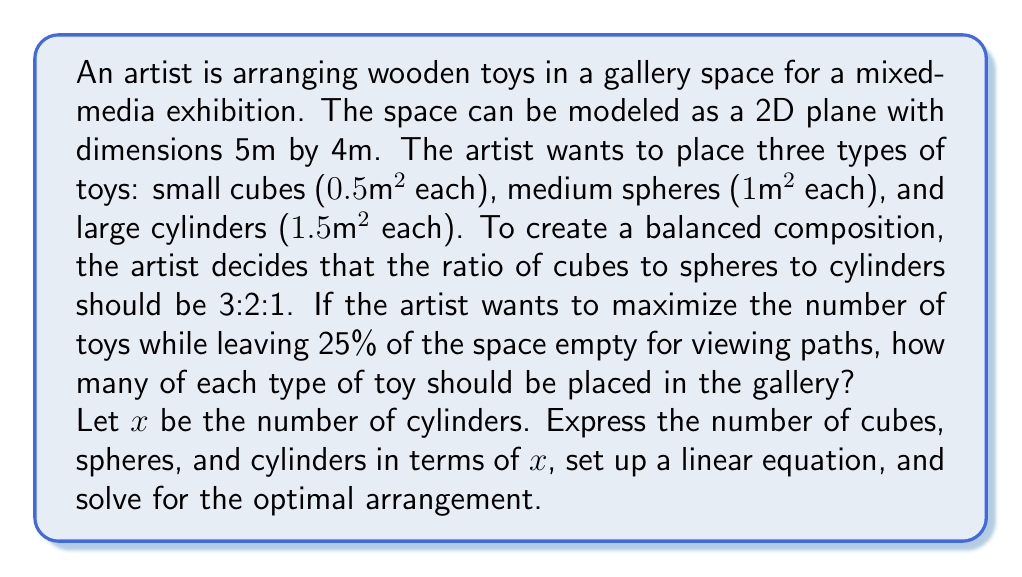Solve this math problem. Let's approach this problem step-by-step:

1) First, let's define our variables:
   $x$ = number of cylinders
   $3x$ = number of cubes (3 times the cylinders)
   $2x$ = number of spheres (2 times the cylinders)

2) Calculate the total area of the gallery:
   $$\text{Total Area} = 5m \times 4m = 20m^2$$

3) Calculate the available area for toys (75% of total):
   $$\text{Available Area} = 0.75 \times 20m^2 = 15m^2$$

4) Set up the equation based on the area occupied by toys:
   $$0.5m^2(3x) + 1m^2(2x) + 1.5m^2(x) = 15m^2$$

5) Simplify the equation:
   $$1.5x + 2x + 1.5x = 15$$
   $$5x = 15$$

6) Solve for $x$:
   $$x = 3$$

7) Calculate the number of each type of toy:
   Cylinders: $x = 3$
   Spheres: $2x = 2(3) = 6$
   Cubes: $3x = 3(3) = 9$

8) Verify the solution:
   Total area occupied by toys:
   $$(3 \times 1.5m^2) + (6 \times 1m^2) + (9 \times 0.5m^2) = 4.5m^2 + 6m^2 + 4.5m^2 = 15m^2$$

   This matches our available area, confirming the solution is correct.
Answer: 9 cubes, 6 spheres, 3 cylinders 